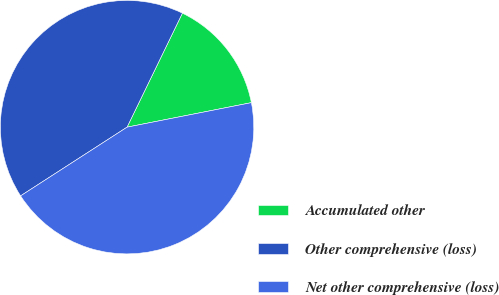<chart> <loc_0><loc_0><loc_500><loc_500><pie_chart><fcel>Accumulated other<fcel>Other comprehensive (loss)<fcel>Net other comprehensive (loss)<nl><fcel>14.71%<fcel>41.32%<fcel>43.98%<nl></chart> 